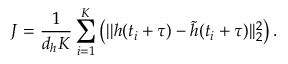Convert formula to latex. <formula><loc_0><loc_0><loc_500><loc_500>J = \frac { 1 } { d _ { h } K } \sum _ { i = 1 } ^ { K } \left ( | | h ( t _ { i } + \tau ) - \tilde { h } ( t _ { i } + \tau ) | | _ { 2 } ^ { 2 } \right ) .</formula> 